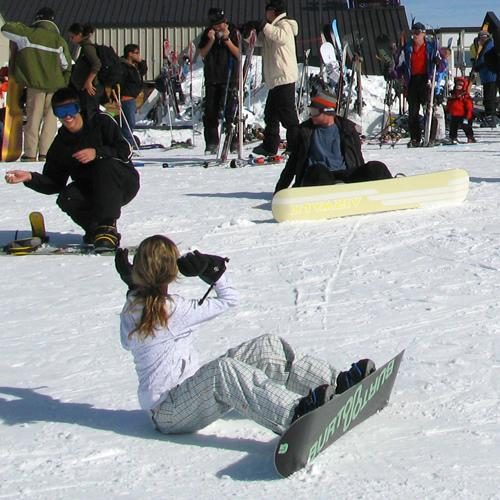What are the people sitting in the snow doing? Please explain your reasoning. waiting. These people appear to be prepared to ski but await something before starting. 